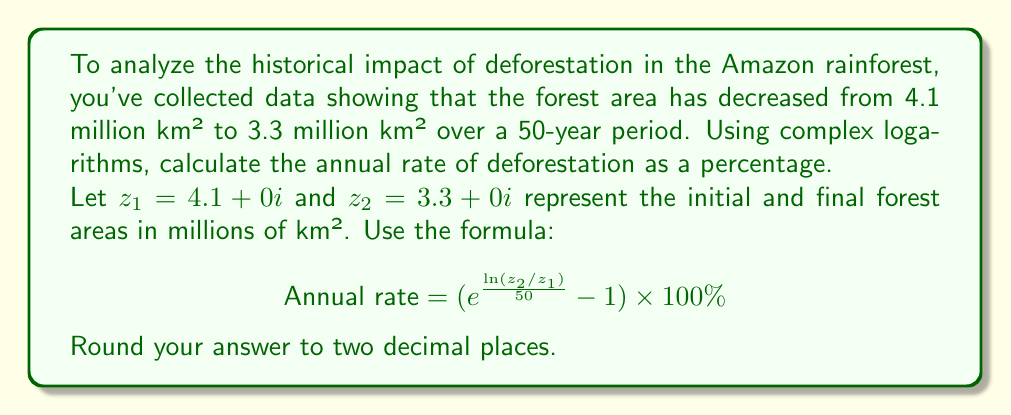Could you help me with this problem? To solve this problem, we'll follow these steps:

1) First, calculate $z_2/z_1$:
   $$\frac{z_2}{z_1} = \frac{3.3 + 0i}{4.1 + 0i} = 0.8048780487804878$$

2) Calculate $\ln(z_2/z_1)$:
   $$\ln(z_2/z_1) = \ln(0.8048780487804878) = -0.2170416440941616$$

3) Divide by 50 (years):
   $$\frac{\ln(z_2/z_1)}{50} = \frac{-0.2170416440941616}{50} = -0.004340832881883232$$

4) Calculate $e$ raised to this power:
   $$e^{\frac{\ln(z_2/z_1)}{50}} = e^{-0.004340832881883232} = 0.9956691699604743$$

5) Subtract 1 and multiply by 100 to get the percentage:
   $$(0.9956691699604743 - 1) \times 100\% = -0.4330830039525714\%$$

6) Round to two decimal places:
   $$-0.43\%$$

The negative sign indicates that the forest area is decreasing.
Answer: $-0.43\%$ 